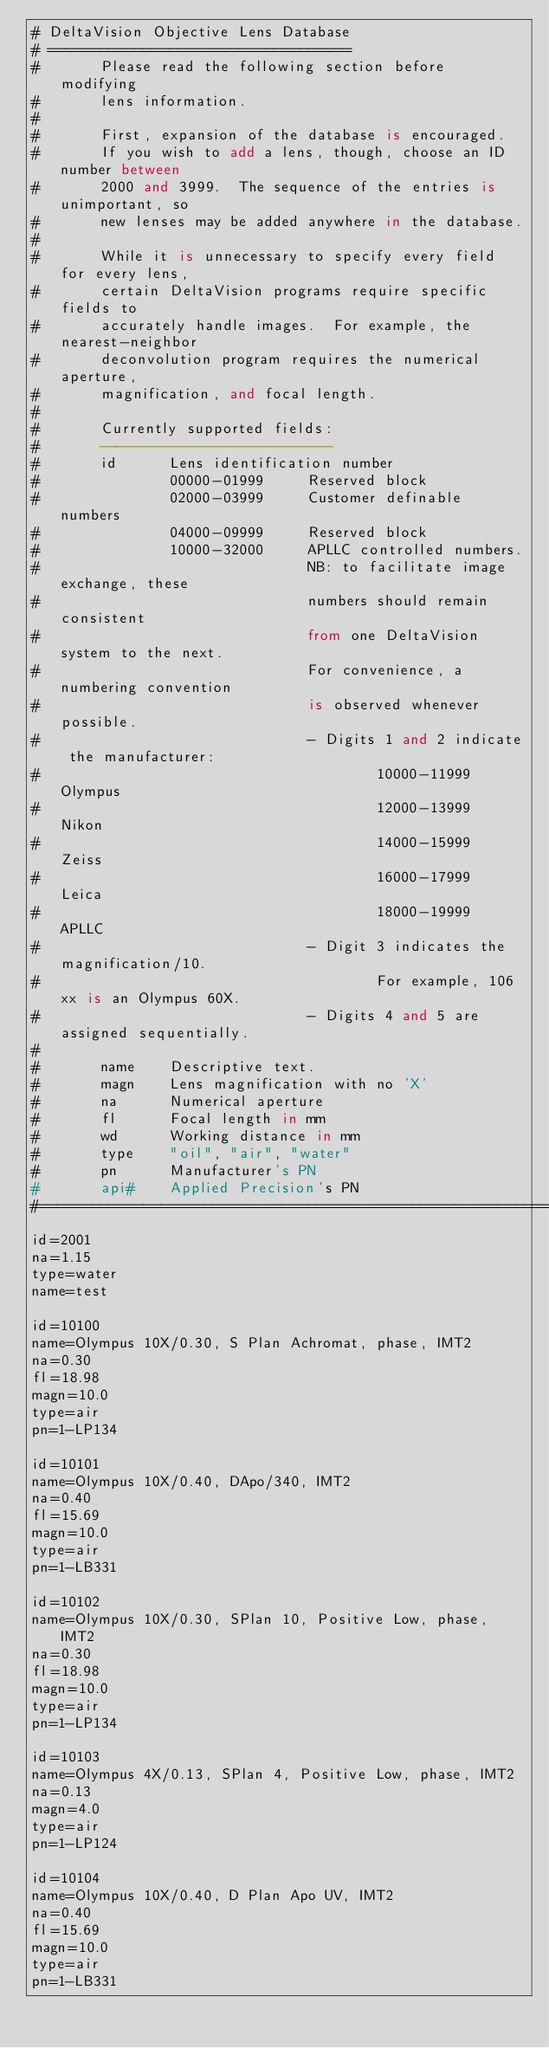Convert code to text. <code><loc_0><loc_0><loc_500><loc_500><_SQL_># DeltaVision Objective Lens Database
# ===================================
#       Please read the following section before modifying 
#       lens information.
#       
#       First, expansion of the database is encouraged.
#       If you wish to add a lens, though, choose an ID number between
#       2000 and 3999.  The sequence of the entries is unimportant, so
#       new lenses may be added anywhere in the database.
#
#       While it is unnecessary to specify every field for every lens,
#       certain DeltaVision programs require specific fields to 
#       accurately handle images.  For example, the nearest-neighbor
#       deconvolution program requires the numerical aperture, 
#       magnification, and focal length.
#
#       Currently supported fields:
#       ---------------------------
#       id      Lens identification number
#               00000-01999     Reserved block
#               02000-03999     Customer definable numbers
#               04000-09999     Reserved block
#               10000-32000     APLLC controlled numbers.
#                               NB: to facilitate image exchange, these
#                               numbers should remain consistent
#                               from one DeltaVision system to the next.
#                               For convenience, a numbering convention
#                               is observed whenever possible.
#                               - Digits 1 and 2 indicate the manufacturer:
#                                       10000-11999     Olympus
#                                       12000-13999     Nikon
#                                       14000-15999     Zeiss
#                                       16000-17999     Leica
#                                       18000-19999     APLLC
#                               - Digit 3 indicates the magnification/10.
#                                       For example, 106xx is an Olympus 60X.
#                               - Digits 4 and 5 are assigned sequentially.
#
#       name    Descriptive text.
#       magn    Lens magnification with no 'X'
#       na      Numerical aperture
#       fl      Focal length in mm
#       wd      Working distance in mm
#       type    "oil", "air", "water"
#       pn      Manufacturer's PN
#       api#    Applied Precision's PN
#======================================================================
id=2001
na=1.15
type=water
name=test

id=10100
name=Olympus 10X/0.30, S Plan Achromat, phase, IMT2
na=0.30
fl=18.98
magn=10.0
type=air
pn=1-LP134

id=10101
name=Olympus 10X/0.40, DApo/340, IMT2
na=0.40
fl=15.69
magn=10.0
type=air
pn=1-LB331

id=10102
name=Olympus 10X/0.30, SPlan 10, Positive Low, phase, IMT2
na=0.30
fl=18.98
magn=10.0
type=air
pn=1-LP134

id=10103
name=Olympus 4X/0.13, SPlan 4, Positive Low, phase, IMT2
na=0.13
magn=4.0
type=air
pn=1-LP124

id=10104
name=Olympus 10X/0.40, D Plan Apo UV, IMT2
na=0.40
fl=15.69
magn=10.0
type=air
pn=1-LB331
</code> 